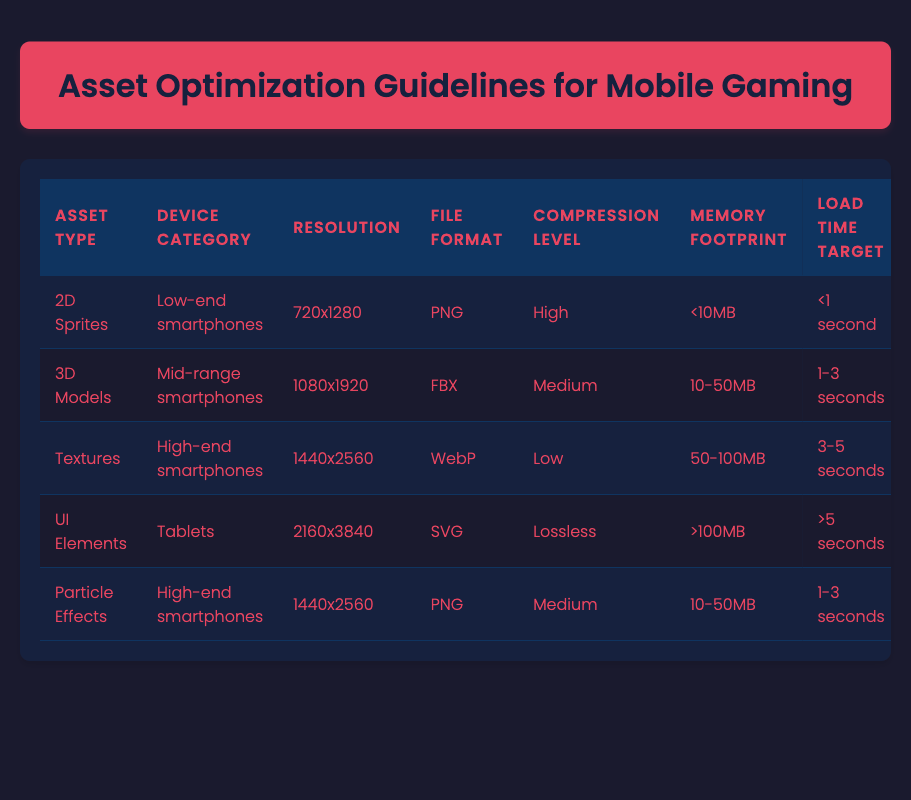What is the file format used for 2D Sprites? The table shows that for 2D Sprites, the file format is PNG. This information can be found directly in the corresponding row for 2D Sprites.
Answer: PNG Which asset type has a load time target of less than 1 second? According to the table, the asset type with a load time target of less than 1 second is 2D Sprites. This is identified by looking at the load time column for each asset type.
Answer: 2D Sprites Is the memory footprint for UI Elements greater than 100MB? The table indicates that UI Elements have a memory footprint of greater than 100MB, as stated in the relevant row. This is a true fact based on the data provided.
Answer: Yes How many asset types can use a resolution of 1440x2560? The table lists two asset types that have a resolution of 1440x2560: Textures and Particle Effects. Thus, by counting these two rows, we find that there are 2 asset types.
Answer: 2 What is the optimization technique used for 3D Models? For 3D Models, the optimization technique listed in the table is Mesh decimation. This can be seen in the corresponding row under the optimization technique column.
Answer: Mesh decimation Which asset type has the lowest compression level and what device category and file format does it use? The asset type with the lowest compression level (Low) is Textures. It is categorized under High-end smartphones and uses the WebP file format, as evidenced by checking the respective columns in its row.
Answer: Textures; High-end smartphones; WebP How many different file formats are used across all asset types? The table features four distinct file formats: PNG, JPEG, WebP, and SVG, across various asset types. By listing these formats under the file format column, we can confirm there are 4 formats.
Answer: 4 What is the average memory footprint of asset types targeting a load time of 1-3 seconds? The asset types with a load time target of 1-3 seconds are 3D Models and Particle Effects. Their memory footprints are 10-50MB for both. Since both fall in the same range, the average is also 10-50MB. Therefore, the average memory footprint remains 10-50MB.
Answer: 10-50MB Is there an asset type that utilizes Lossless compression and a file format of SVG? Yes, the asset type UI Elements uses Lossless compression and the SVG file format, as confirmed by looking at the respective values in its row under the compression level and file format columns.
Answer: Yes 